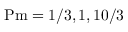<formula> <loc_0><loc_0><loc_500><loc_500>P m = 1 / 3 , 1 , 1 0 / 3</formula> 